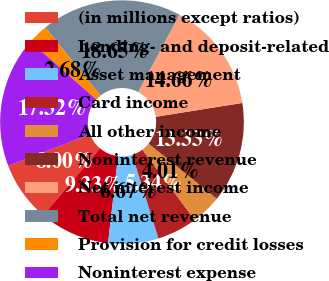Convert chart. <chart><loc_0><loc_0><loc_500><loc_500><pie_chart><fcel>(in millions except ratios)<fcel>Lending- and deposit-related<fcel>Asset management<fcel>Card income<fcel>All other income<fcel>Noninterest revenue<fcel>Net interest income<fcel>Total net revenue<fcel>Provision for credit losses<fcel>Noninterest expense<nl><fcel>8.0%<fcel>9.33%<fcel>6.67%<fcel>5.34%<fcel>4.01%<fcel>13.33%<fcel>14.66%<fcel>18.65%<fcel>2.68%<fcel>17.32%<nl></chart> 